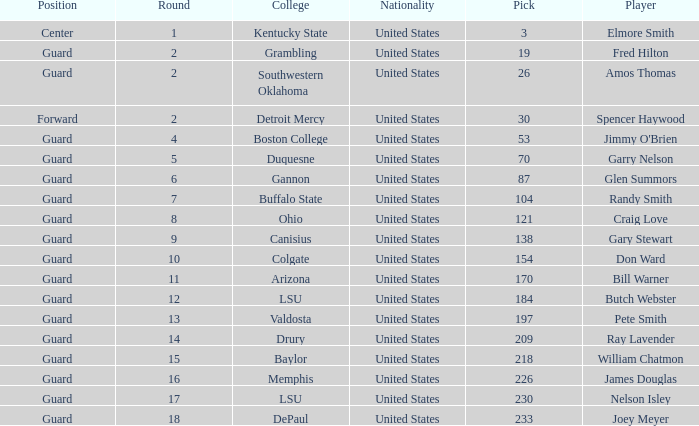WHAT IS THE TOTAL PICK FOR BOSTON COLLEGE? 1.0. 